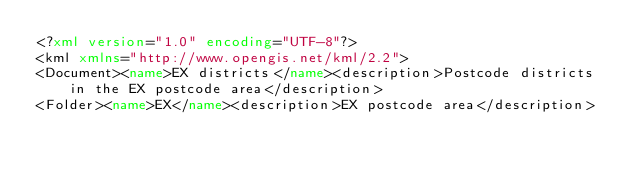Convert code to text. <code><loc_0><loc_0><loc_500><loc_500><_XML_><?xml version="1.0" encoding="UTF-8"?>
<kml xmlns="http://www.opengis.net/kml/2.2">
<Document><name>EX districts</name><description>Postcode districts in the EX postcode area</description>
<Folder><name>EX</name><description>EX postcode area</description></code> 